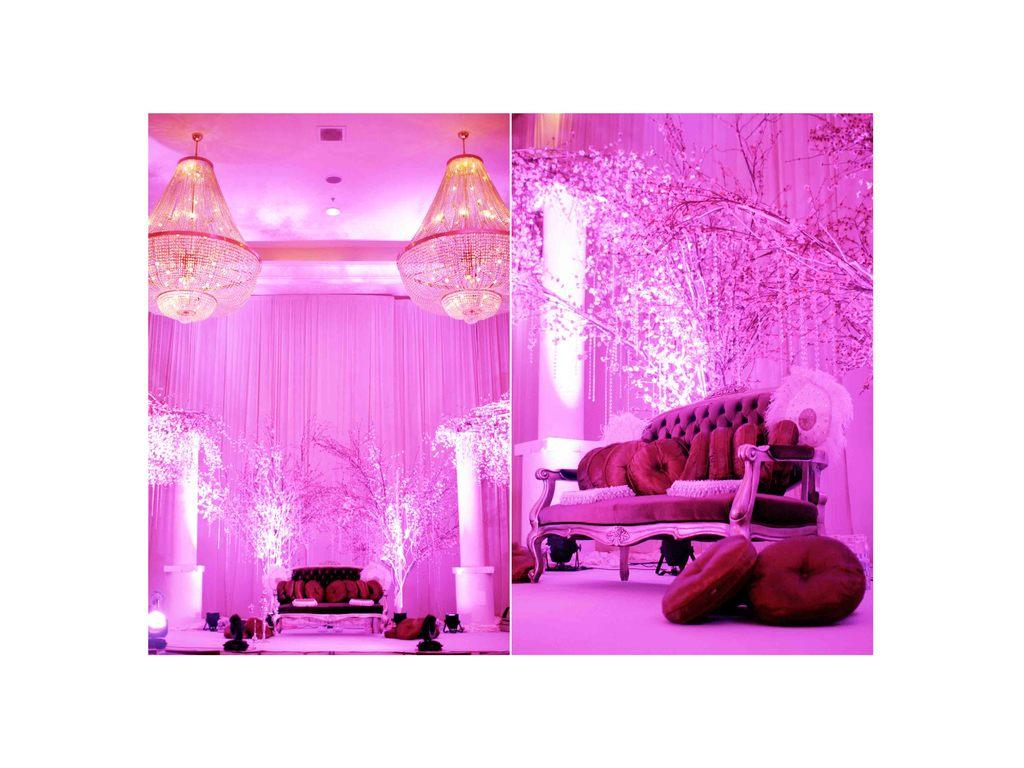How many pictures are in the image? There are two pictures in the image. What can be seen in the pictures? In the pictures, there are pillows, couches, plants, chandeliers, a ceiling light, curtains, and focusing lights. What type of objects are present in the pictures? In the pictures, there are objects, but their specific nature is not mentioned. What type of pleasure can be seen in the image? There is no mention of pleasure in the image; it features two pictures with various elements, as described in the conversation. How many lamps are visible in the image? There is no mention of lamps in the image; it features two pictures with various elements, including chandeliers and a ceiling light. 